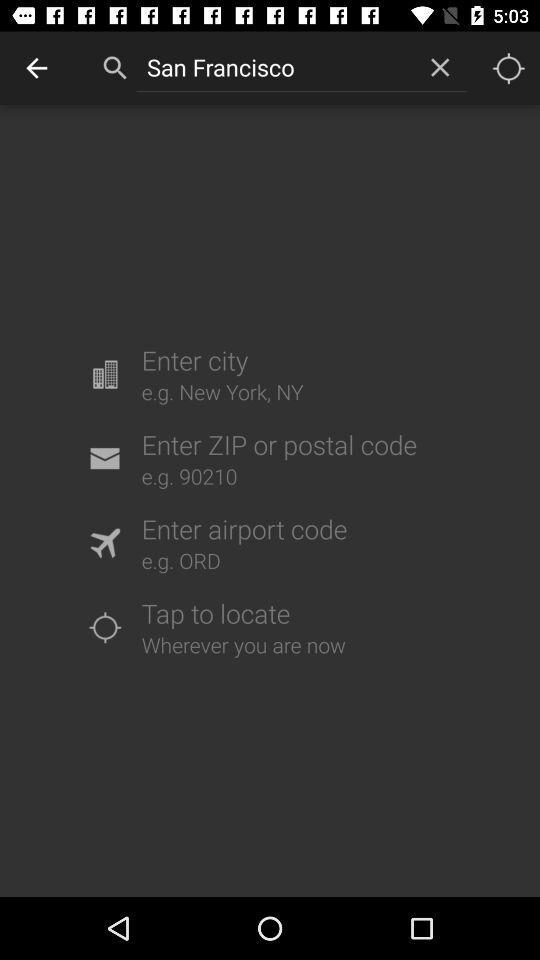What is the text entered in the input field? The entered text is "San Francisco". 